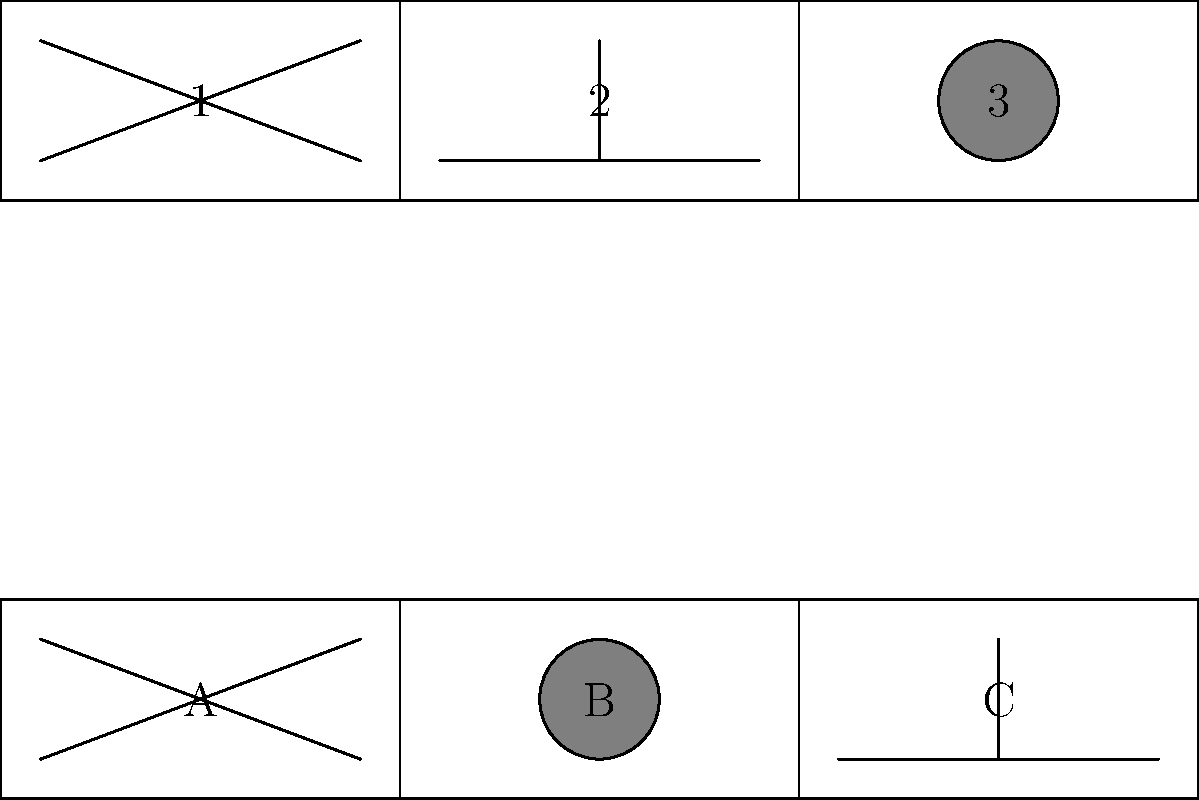Match the storyboard sketches (1, 2, 3) with their corresponding iconic film scenes (A, B, C). Which pairing represents the famous "Here's Johnny!" scene from Stanley Kubrick's "The Shining"? To answer this question, we need to analyze each storyboard sketch and match it to the corresponding film scene:

1. Sketch 1 shows two diagonal lines intersecting, forming an "X" shape. This is a classic representation of an axe breaking through a door, which is the iconic "Here's Johnny!" scene from "The Shining."

2. Sketch 2 depicts a vertical line intersecting a horizontal line, resembling a window or doorframe. This doesn't match any of the given film scenes.

3. Sketch 3 shows a circle, which could represent a close-up shot or a porthole. This matches Scene B, which also shows a circle.

4. Scene A shows an "X" shape, matching Sketch 1.

5. Scene B shows a circle, matching Sketch 3.

6. Scene C shows a "T" shape, which doesn't directly correspond to any of the sketches.

Based on this analysis, we can conclude that Sketch 1 matches Scene A, representing the "Here's Johnny!" scene from "The Shining."
Answer: 1-A 